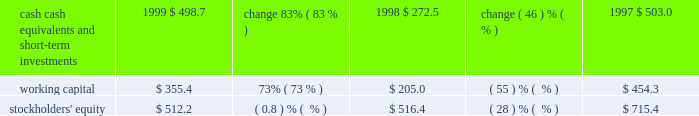Liquidity and capital resources .
Our cash , cash equivalents , and short-term investments consist principally of money market mutual funds , municipal bonds , and united states government agency securities .
All of our cash equivalents and short-term investments are classified as available-for-sale under the provisions of sfas 115 , 2018 2018accounting for certain investments in debt and equity securities . 2019 2019 the securities are carried at fair value with the unrealized gains and losses , net of tax , included in accumulated other comprehensive income , which is reflected as a separate component of stockholders 2019 equity .
Our cash , cash equivalents , and short-term investments increased $ 226.2 million , or 83% ( 83 % ) , in fiscal 1999 , primarily due to cash generated from operations of $ 334.2 million , proceeds from the issuance of treasury stock related to the exercise of stock options under our stock option plans and sale of stock under the employee stock purchase plan of $ 142.9 million , and the release of restricted funds totaling $ 130.3 million associated with the refinancing of our corporate headquarters lease agreement .
Other sources of cash include the proceeds from the sale of equity securities and the sale of a building in the amount of $ 63.9 million and $ 40.6 million , respectively .
In addition , short-term investments increased due to a reclassification of $ 46.7 million of investments classified as long-term to short-term as well as mark-to-market adjustments totaling $ 81.2 million .
These factors were partially offset by the purchase of treasury stock in the amount of $ 479.2 million , capital expenditures of $ 42.2 million , the purchase of other assets for $ 43.5 million , the purchase of the assets of golive systems and attitude software for $ 36.9 million , and the payment of dividends totaling $ 12.2 million .
We expect to continue our investing activities , including expenditures for computer systems for research and development , sales and marketing , product support , and administrative staff .
Furthermore , cash reserves may be used to purchase treasury stock and acquire software companies , products , or technologies that are complementary to our business .
In september 1997 , adobe 2019s board of directors authorized , subject to certain business and market conditions , the purchase of up to 30.0 million shares of our common stock over a two-year period .
We repurchased approximately 1.7 million shares in the first quarter of fiscal 1999 , 20.3 million shares in fiscal 1998 , and 8.0 million shares in fiscal 1997 , at a cost of $ 30.5 million , $ 362.4 million , and $ 188.6 million , respectively .
This program was completed during the first quarter of fiscal 1999 .
In april 1999 , adobe 2019s board of directors authorized , subject to certain business and market conditions , the purchase of up to an additional 5.0 million shares of our common stock over a two-year period .
This new stock repurchase program was in addition to an existing program whereby we have been authorized to repurchase shares to offset issuances under employee stock option and stock purchase plans .
No purchases have been made under the 5.0 million share repurchase program .
Under our existing plan to repurchase shares to offset issuances under employee stock plans , we repurchased approximately 11.2 million , 0.7 million , and 4.6 million shares in fiscal 1999 , 1998 , and 1997 , respectively , at a cost of $ 448.7 million , $ 16.8 million , and $ 87.0 million , respectively .
We have paid cash dividends on our common stock each quarter since the second quarter of 1988 .
Adobe 2019s board of directors declared a cash dividend on our common stock of $ 0.025 per common share for each of the four quarters in fiscal 1999 , 1998 , and 1997 .
On december 1 , 1997 , we dividended one share of siebel common stock for each 600 shares of adobe common stock held by stockholders of record on october 31 , 1997 .
An equivalent cash dividend was paid for holdings of less than 15000 adobe shares and .
What percentage of cash , cash equivalents , and short-term investments was due to cash generated from operations? 
Computations: (334.2 / 226.2)
Answer: 1.47745. 